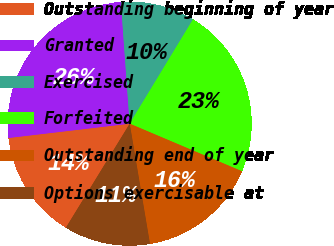Convert chart to OTSL. <chart><loc_0><loc_0><loc_500><loc_500><pie_chart><fcel>Outstanding beginning of year<fcel>Granted<fcel>Exercised<fcel>Forfeited<fcel>Outstanding end of year<fcel>Options exercisable at<nl><fcel>14.37%<fcel>25.72%<fcel>9.83%<fcel>22.69%<fcel>15.96%<fcel>11.42%<nl></chart> 